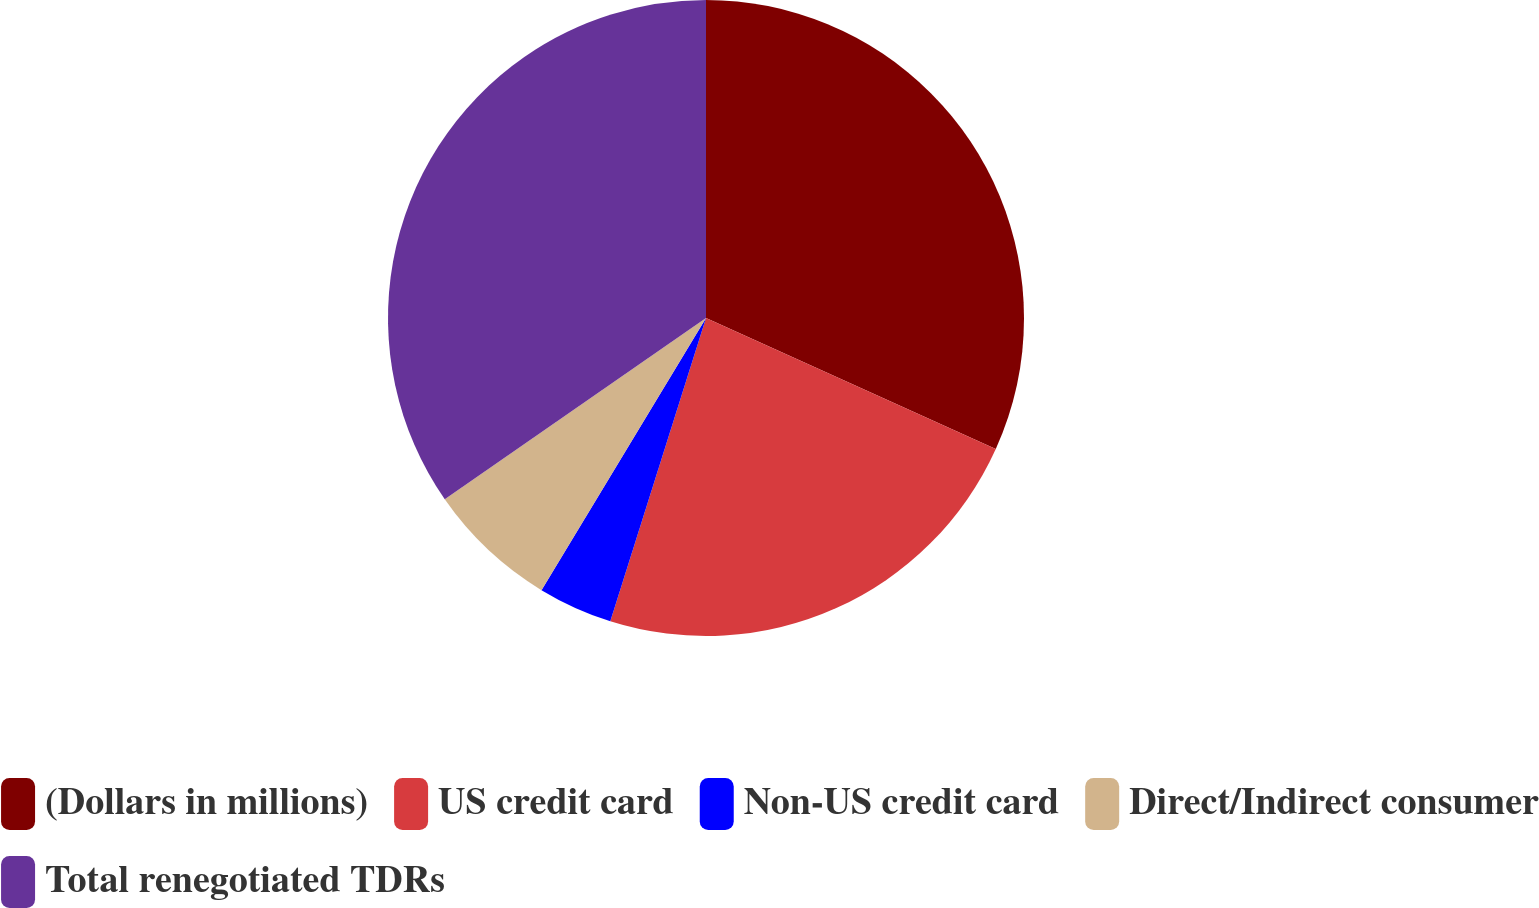Convert chart to OTSL. <chart><loc_0><loc_0><loc_500><loc_500><pie_chart><fcel>(Dollars in millions)<fcel>US credit card<fcel>Non-US credit card<fcel>Direct/Indirect consumer<fcel>Total renegotiated TDRs<nl><fcel>31.76%<fcel>23.11%<fcel>3.79%<fcel>6.69%<fcel>34.66%<nl></chart> 